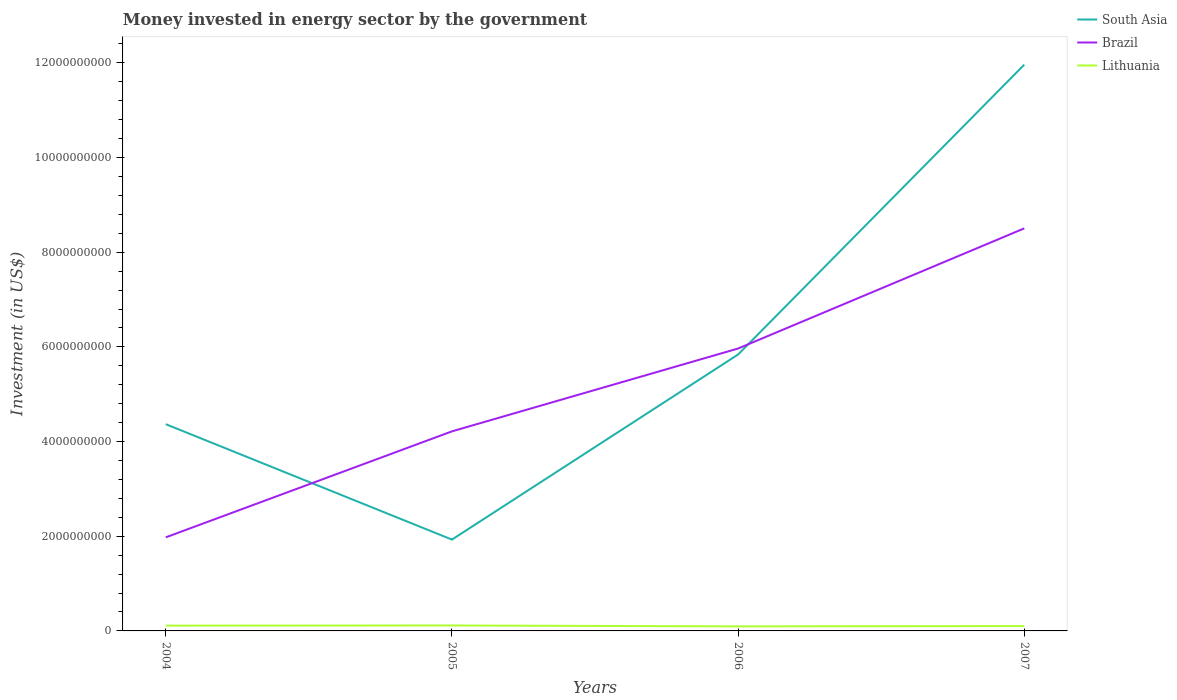Is the number of lines equal to the number of legend labels?
Keep it short and to the point. Yes. Across all years, what is the maximum money spent in energy sector in South Asia?
Your response must be concise. 1.93e+09. In which year was the money spent in energy sector in Lithuania maximum?
Your answer should be very brief. 2006. What is the total money spent in energy sector in Brazil in the graph?
Keep it short and to the point. -2.24e+09. What is the difference between the highest and the second highest money spent in energy sector in South Asia?
Offer a very short reply. 1.00e+1. What is the difference between the highest and the lowest money spent in energy sector in Brazil?
Keep it short and to the point. 2. How many years are there in the graph?
Offer a terse response. 4. Does the graph contain any zero values?
Your response must be concise. No. Does the graph contain grids?
Provide a succinct answer. No. Where does the legend appear in the graph?
Offer a very short reply. Top right. How are the legend labels stacked?
Your answer should be very brief. Vertical. What is the title of the graph?
Give a very brief answer. Money invested in energy sector by the government. What is the label or title of the Y-axis?
Your response must be concise. Investment (in US$). What is the Investment (in US$) of South Asia in 2004?
Your answer should be very brief. 4.37e+09. What is the Investment (in US$) in Brazil in 2004?
Make the answer very short. 1.98e+09. What is the Investment (in US$) in Lithuania in 2004?
Offer a very short reply. 1.12e+08. What is the Investment (in US$) of South Asia in 2005?
Provide a short and direct response. 1.93e+09. What is the Investment (in US$) in Brazil in 2005?
Ensure brevity in your answer.  4.22e+09. What is the Investment (in US$) in Lithuania in 2005?
Offer a very short reply. 1.15e+08. What is the Investment (in US$) of South Asia in 2006?
Make the answer very short. 5.84e+09. What is the Investment (in US$) of Brazil in 2006?
Provide a short and direct response. 5.97e+09. What is the Investment (in US$) of Lithuania in 2006?
Make the answer very short. 9.60e+07. What is the Investment (in US$) in South Asia in 2007?
Provide a succinct answer. 1.20e+1. What is the Investment (in US$) of Brazil in 2007?
Ensure brevity in your answer.  8.50e+09. What is the Investment (in US$) in Lithuania in 2007?
Keep it short and to the point. 1.03e+08. Across all years, what is the maximum Investment (in US$) of South Asia?
Offer a very short reply. 1.20e+1. Across all years, what is the maximum Investment (in US$) of Brazil?
Your answer should be very brief. 8.50e+09. Across all years, what is the maximum Investment (in US$) of Lithuania?
Offer a terse response. 1.15e+08. Across all years, what is the minimum Investment (in US$) of South Asia?
Your response must be concise. 1.93e+09. Across all years, what is the minimum Investment (in US$) of Brazil?
Give a very brief answer. 1.98e+09. Across all years, what is the minimum Investment (in US$) in Lithuania?
Keep it short and to the point. 9.60e+07. What is the total Investment (in US$) in South Asia in the graph?
Offer a terse response. 2.41e+1. What is the total Investment (in US$) in Brazil in the graph?
Provide a succinct answer. 2.07e+1. What is the total Investment (in US$) in Lithuania in the graph?
Offer a terse response. 4.26e+08. What is the difference between the Investment (in US$) in South Asia in 2004 and that in 2005?
Keep it short and to the point. 2.44e+09. What is the difference between the Investment (in US$) of Brazil in 2004 and that in 2005?
Offer a very short reply. -2.24e+09. What is the difference between the Investment (in US$) of Lithuania in 2004 and that in 2005?
Provide a short and direct response. -3.20e+06. What is the difference between the Investment (in US$) in South Asia in 2004 and that in 2006?
Keep it short and to the point. -1.47e+09. What is the difference between the Investment (in US$) of Brazil in 2004 and that in 2006?
Ensure brevity in your answer.  -3.99e+09. What is the difference between the Investment (in US$) in Lithuania in 2004 and that in 2006?
Make the answer very short. 1.58e+07. What is the difference between the Investment (in US$) in South Asia in 2004 and that in 2007?
Offer a very short reply. -7.59e+09. What is the difference between the Investment (in US$) in Brazil in 2004 and that in 2007?
Keep it short and to the point. -6.53e+09. What is the difference between the Investment (in US$) of Lithuania in 2004 and that in 2007?
Provide a short and direct response. 8.80e+06. What is the difference between the Investment (in US$) of South Asia in 2005 and that in 2006?
Give a very brief answer. -3.91e+09. What is the difference between the Investment (in US$) in Brazil in 2005 and that in 2006?
Your answer should be very brief. -1.75e+09. What is the difference between the Investment (in US$) in Lithuania in 2005 and that in 2006?
Offer a terse response. 1.90e+07. What is the difference between the Investment (in US$) in South Asia in 2005 and that in 2007?
Ensure brevity in your answer.  -1.00e+1. What is the difference between the Investment (in US$) of Brazil in 2005 and that in 2007?
Your answer should be compact. -4.29e+09. What is the difference between the Investment (in US$) of South Asia in 2006 and that in 2007?
Your answer should be compact. -6.12e+09. What is the difference between the Investment (in US$) of Brazil in 2006 and that in 2007?
Offer a terse response. -2.54e+09. What is the difference between the Investment (in US$) in Lithuania in 2006 and that in 2007?
Keep it short and to the point. -7.00e+06. What is the difference between the Investment (in US$) of South Asia in 2004 and the Investment (in US$) of Brazil in 2005?
Give a very brief answer. 1.52e+08. What is the difference between the Investment (in US$) of South Asia in 2004 and the Investment (in US$) of Lithuania in 2005?
Ensure brevity in your answer.  4.25e+09. What is the difference between the Investment (in US$) in Brazil in 2004 and the Investment (in US$) in Lithuania in 2005?
Your answer should be compact. 1.86e+09. What is the difference between the Investment (in US$) of South Asia in 2004 and the Investment (in US$) of Brazil in 2006?
Your answer should be compact. -1.60e+09. What is the difference between the Investment (in US$) of South Asia in 2004 and the Investment (in US$) of Lithuania in 2006?
Your answer should be compact. 4.27e+09. What is the difference between the Investment (in US$) in Brazil in 2004 and the Investment (in US$) in Lithuania in 2006?
Make the answer very short. 1.88e+09. What is the difference between the Investment (in US$) of South Asia in 2004 and the Investment (in US$) of Brazil in 2007?
Offer a terse response. -4.14e+09. What is the difference between the Investment (in US$) in South Asia in 2004 and the Investment (in US$) in Lithuania in 2007?
Keep it short and to the point. 4.26e+09. What is the difference between the Investment (in US$) in Brazil in 2004 and the Investment (in US$) in Lithuania in 2007?
Your response must be concise. 1.87e+09. What is the difference between the Investment (in US$) of South Asia in 2005 and the Investment (in US$) of Brazil in 2006?
Ensure brevity in your answer.  -4.04e+09. What is the difference between the Investment (in US$) in South Asia in 2005 and the Investment (in US$) in Lithuania in 2006?
Ensure brevity in your answer.  1.83e+09. What is the difference between the Investment (in US$) of Brazil in 2005 and the Investment (in US$) of Lithuania in 2006?
Give a very brief answer. 4.12e+09. What is the difference between the Investment (in US$) in South Asia in 2005 and the Investment (in US$) in Brazil in 2007?
Provide a succinct answer. -6.58e+09. What is the difference between the Investment (in US$) in South Asia in 2005 and the Investment (in US$) in Lithuania in 2007?
Offer a very short reply. 1.83e+09. What is the difference between the Investment (in US$) of Brazil in 2005 and the Investment (in US$) of Lithuania in 2007?
Your answer should be very brief. 4.11e+09. What is the difference between the Investment (in US$) of South Asia in 2006 and the Investment (in US$) of Brazil in 2007?
Your answer should be very brief. -2.66e+09. What is the difference between the Investment (in US$) of South Asia in 2006 and the Investment (in US$) of Lithuania in 2007?
Make the answer very short. 5.74e+09. What is the difference between the Investment (in US$) of Brazil in 2006 and the Investment (in US$) of Lithuania in 2007?
Keep it short and to the point. 5.86e+09. What is the average Investment (in US$) in South Asia per year?
Keep it short and to the point. 6.02e+09. What is the average Investment (in US$) in Brazil per year?
Ensure brevity in your answer.  5.17e+09. What is the average Investment (in US$) in Lithuania per year?
Make the answer very short. 1.06e+08. In the year 2004, what is the difference between the Investment (in US$) of South Asia and Investment (in US$) of Brazil?
Your answer should be very brief. 2.39e+09. In the year 2004, what is the difference between the Investment (in US$) of South Asia and Investment (in US$) of Lithuania?
Your answer should be very brief. 4.26e+09. In the year 2004, what is the difference between the Investment (in US$) of Brazil and Investment (in US$) of Lithuania?
Your answer should be compact. 1.87e+09. In the year 2005, what is the difference between the Investment (in US$) in South Asia and Investment (in US$) in Brazil?
Ensure brevity in your answer.  -2.29e+09. In the year 2005, what is the difference between the Investment (in US$) of South Asia and Investment (in US$) of Lithuania?
Give a very brief answer. 1.81e+09. In the year 2005, what is the difference between the Investment (in US$) in Brazil and Investment (in US$) in Lithuania?
Offer a very short reply. 4.10e+09. In the year 2006, what is the difference between the Investment (in US$) of South Asia and Investment (in US$) of Brazil?
Keep it short and to the point. -1.26e+08. In the year 2006, what is the difference between the Investment (in US$) of South Asia and Investment (in US$) of Lithuania?
Offer a very short reply. 5.74e+09. In the year 2006, what is the difference between the Investment (in US$) of Brazil and Investment (in US$) of Lithuania?
Offer a very short reply. 5.87e+09. In the year 2007, what is the difference between the Investment (in US$) in South Asia and Investment (in US$) in Brazil?
Ensure brevity in your answer.  3.46e+09. In the year 2007, what is the difference between the Investment (in US$) in South Asia and Investment (in US$) in Lithuania?
Offer a very short reply. 1.19e+1. In the year 2007, what is the difference between the Investment (in US$) in Brazil and Investment (in US$) in Lithuania?
Ensure brevity in your answer.  8.40e+09. What is the ratio of the Investment (in US$) in South Asia in 2004 to that in 2005?
Give a very brief answer. 2.26. What is the ratio of the Investment (in US$) in Brazil in 2004 to that in 2005?
Give a very brief answer. 0.47. What is the ratio of the Investment (in US$) of Lithuania in 2004 to that in 2005?
Your answer should be compact. 0.97. What is the ratio of the Investment (in US$) of South Asia in 2004 to that in 2006?
Give a very brief answer. 0.75. What is the ratio of the Investment (in US$) in Brazil in 2004 to that in 2006?
Your response must be concise. 0.33. What is the ratio of the Investment (in US$) of Lithuania in 2004 to that in 2006?
Offer a very short reply. 1.16. What is the ratio of the Investment (in US$) in South Asia in 2004 to that in 2007?
Provide a succinct answer. 0.37. What is the ratio of the Investment (in US$) of Brazil in 2004 to that in 2007?
Your answer should be compact. 0.23. What is the ratio of the Investment (in US$) in Lithuania in 2004 to that in 2007?
Provide a short and direct response. 1.09. What is the ratio of the Investment (in US$) of South Asia in 2005 to that in 2006?
Give a very brief answer. 0.33. What is the ratio of the Investment (in US$) of Brazil in 2005 to that in 2006?
Keep it short and to the point. 0.71. What is the ratio of the Investment (in US$) in Lithuania in 2005 to that in 2006?
Your answer should be compact. 1.2. What is the ratio of the Investment (in US$) of South Asia in 2005 to that in 2007?
Ensure brevity in your answer.  0.16. What is the ratio of the Investment (in US$) in Brazil in 2005 to that in 2007?
Your answer should be compact. 0.5. What is the ratio of the Investment (in US$) in Lithuania in 2005 to that in 2007?
Provide a short and direct response. 1.12. What is the ratio of the Investment (in US$) of South Asia in 2006 to that in 2007?
Provide a short and direct response. 0.49. What is the ratio of the Investment (in US$) in Brazil in 2006 to that in 2007?
Your answer should be compact. 0.7. What is the ratio of the Investment (in US$) in Lithuania in 2006 to that in 2007?
Offer a terse response. 0.93. What is the difference between the highest and the second highest Investment (in US$) in South Asia?
Provide a succinct answer. 6.12e+09. What is the difference between the highest and the second highest Investment (in US$) in Brazil?
Offer a very short reply. 2.54e+09. What is the difference between the highest and the second highest Investment (in US$) of Lithuania?
Your answer should be very brief. 3.20e+06. What is the difference between the highest and the lowest Investment (in US$) of South Asia?
Provide a succinct answer. 1.00e+1. What is the difference between the highest and the lowest Investment (in US$) of Brazil?
Offer a terse response. 6.53e+09. What is the difference between the highest and the lowest Investment (in US$) in Lithuania?
Make the answer very short. 1.90e+07. 